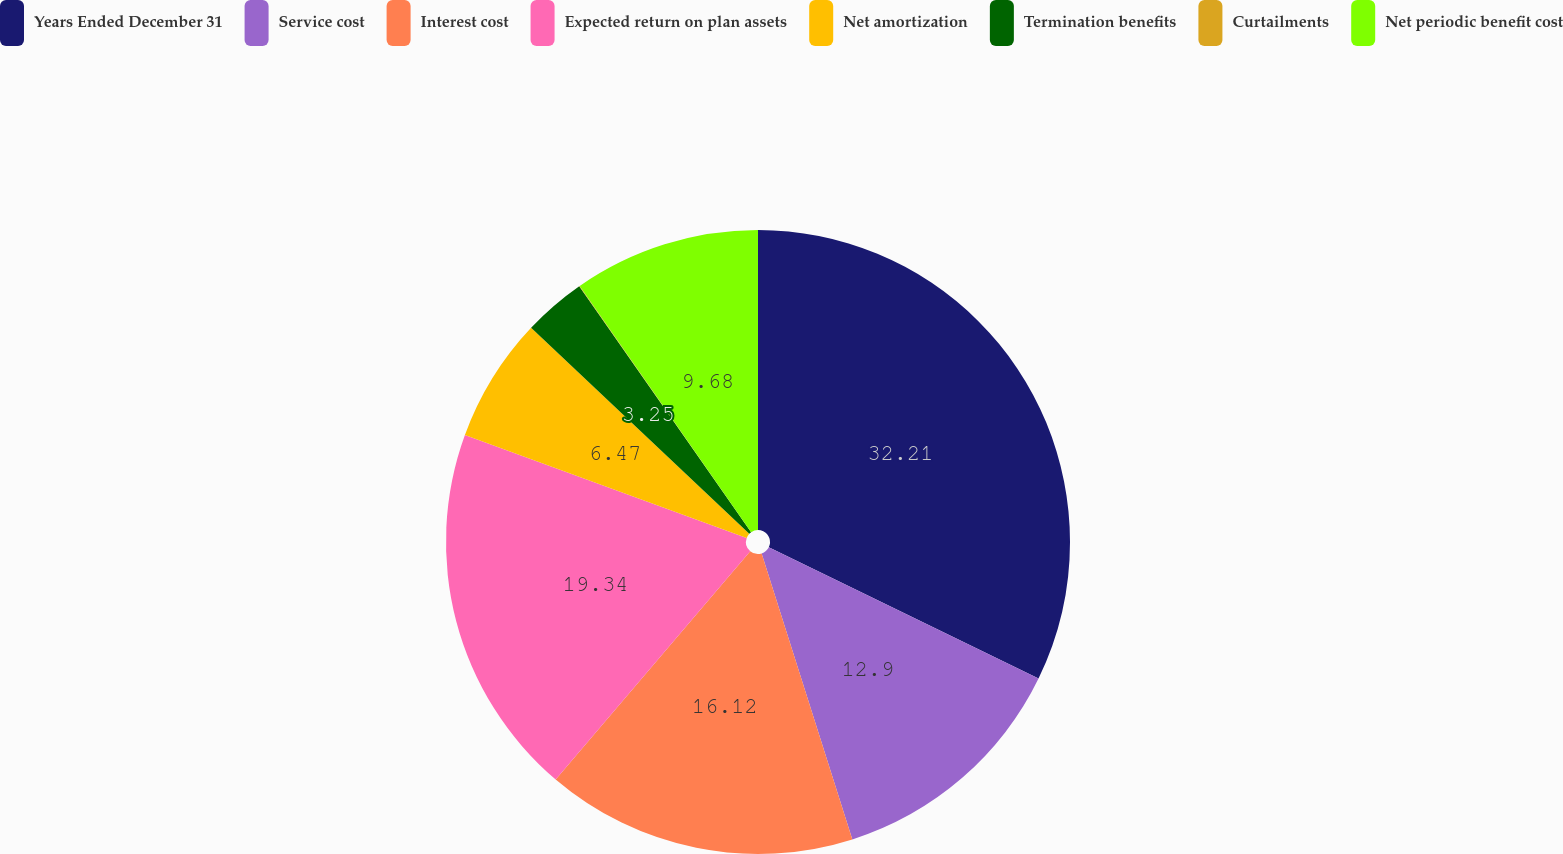<chart> <loc_0><loc_0><loc_500><loc_500><pie_chart><fcel>Years Ended December 31<fcel>Service cost<fcel>Interest cost<fcel>Expected return on plan assets<fcel>Net amortization<fcel>Termination benefits<fcel>Curtailments<fcel>Net periodic benefit cost<nl><fcel>32.21%<fcel>12.9%<fcel>16.12%<fcel>19.34%<fcel>6.47%<fcel>3.25%<fcel>0.03%<fcel>9.68%<nl></chart> 